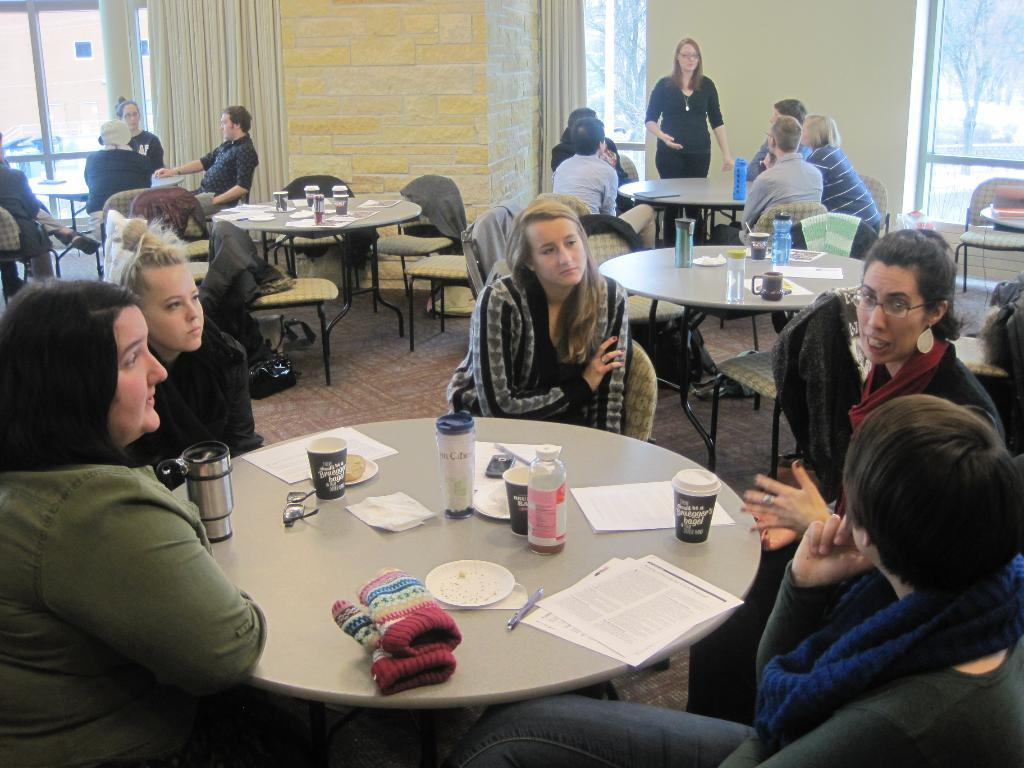What can be seen in the image involving a group of people? There is a group of people in the image. Can you describe the woman on the right side of the image? The woman on the right side of the image is standing. What objects are on the table in the image? There is a bottle, a glass, a paper, and a pen on the table in the image. What color is the orange on the table in the image? There is no orange present on the table in the image. What channel is the group of people watching in the image? There is no television or channel visible in the image. 